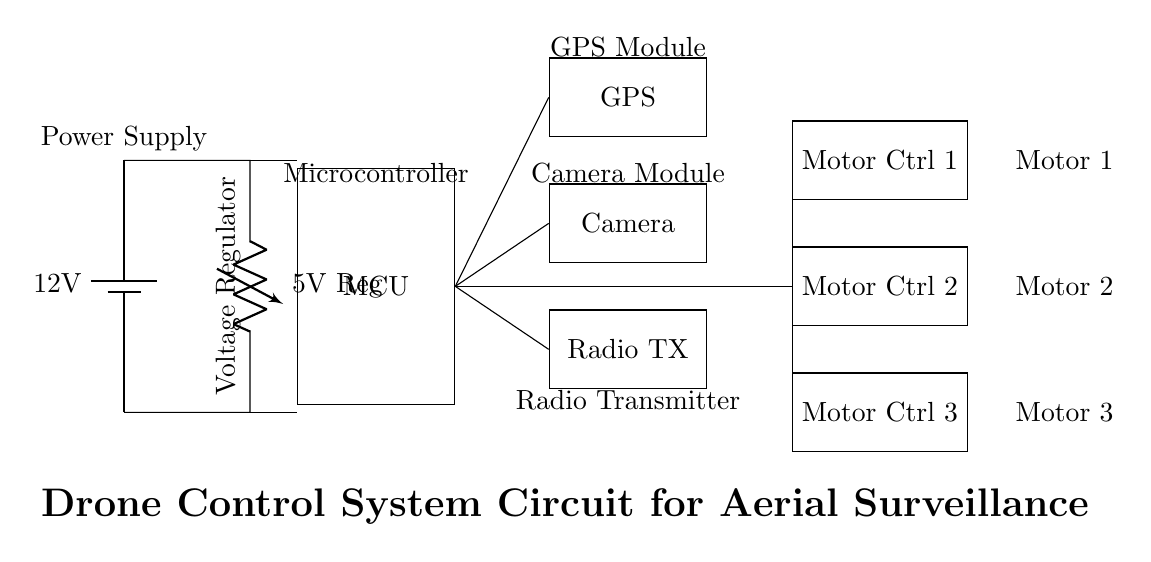What is the main power supply voltage for the circuit? The main power supply voltage is 12 volts, as indicated in the battery symbol at the beginning of the circuit diagram.
Answer: 12 volts What is the output voltage of the voltage regulator? The output voltage of the voltage regulator is 5 volts, which is shown next to the voltage regulator symbol in the circuit.
Answer: 5 volts How many motor controllers are present in the circuit? There are three motor controllers in the circuit, as seen from the three distinct blocks labeled "Motor Ctrl 1," "Motor Ctrl 2," and "Motor Ctrl 3."
Answer: Three What component interfaces with the microcontroller for positioning? The GPS module interfaces with the microcontroller for positioning, as there is a direct connection from the microcontroller to the GPS module in the circuit diagram.
Answer: GPS module Which component is responsible for transmitting data? The Radio Transmitter is responsible for transmitting data, as indicated in the circuit where it connects directly to the microcontroller for communication purposes.
Answer: Radio Transmitter What is the function of the microcontroller in this circuit? The microcontroller’s function is to process inputs from connected components like the GPS and Camera modules and control the motor controllers to help navigate the drone. This can be inferred from its central role in the connections to various components.
Answer: Processing and control Which component powers the entire system? The battery powers the entire system, providing the initial voltage that is regulated down to power other components. This is evident from its position as the power source at the top of the diagram.
Answer: Battery 